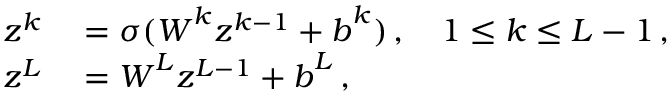<formula> <loc_0><loc_0><loc_500><loc_500>\begin{array} { r l } { \boldsymbol z ^ { k } } & = \sigma ( \boldsymbol W ^ { k } \boldsymbol z ^ { k - 1 } + \boldsymbol b ^ { k } ) \, , \quad 1 \leq k \leq L - 1 \, , } \\ { \boldsymbol z ^ { L } } & = \boldsymbol W ^ { L } \boldsymbol z ^ { L - 1 } + \boldsymbol b ^ { L } \, , } \end{array}</formula> 